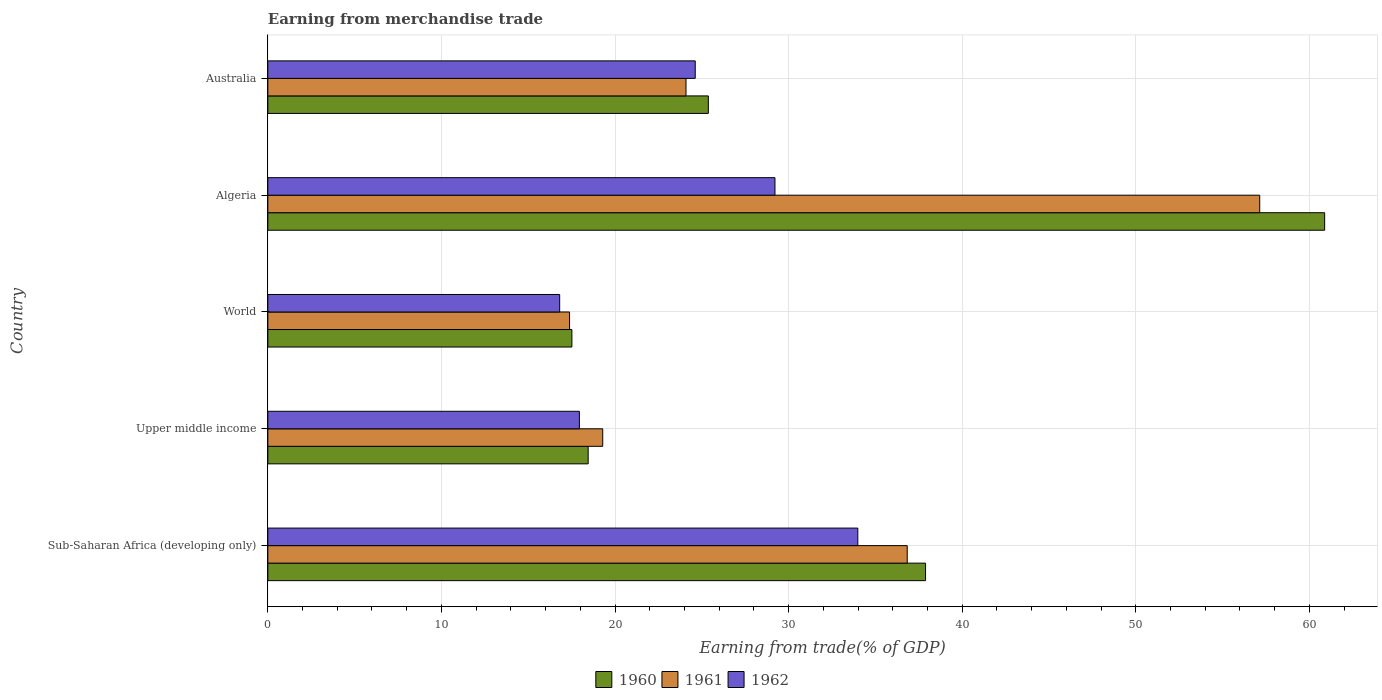How many different coloured bars are there?
Make the answer very short. 3. How many groups of bars are there?
Your answer should be compact. 5. Are the number of bars on each tick of the Y-axis equal?
Your answer should be very brief. Yes. How many bars are there on the 4th tick from the bottom?
Your answer should be compact. 3. What is the label of the 1st group of bars from the top?
Ensure brevity in your answer.  Australia. In how many cases, is the number of bars for a given country not equal to the number of legend labels?
Give a very brief answer. 0. What is the earnings from trade in 1960 in Algeria?
Keep it short and to the point. 60.88. Across all countries, what is the maximum earnings from trade in 1961?
Give a very brief answer. 57.14. Across all countries, what is the minimum earnings from trade in 1961?
Offer a very short reply. 17.38. In which country was the earnings from trade in 1960 maximum?
Give a very brief answer. Algeria. What is the total earnings from trade in 1960 in the graph?
Provide a succinct answer. 160.12. What is the difference between the earnings from trade in 1960 in Algeria and that in Sub-Saharan Africa (developing only)?
Keep it short and to the point. 22.99. What is the difference between the earnings from trade in 1961 in Upper middle income and the earnings from trade in 1962 in World?
Your answer should be very brief. 2.48. What is the average earnings from trade in 1960 per country?
Your response must be concise. 32.02. What is the difference between the earnings from trade in 1960 and earnings from trade in 1962 in Algeria?
Your answer should be compact. 31.67. In how many countries, is the earnings from trade in 1960 greater than 10 %?
Make the answer very short. 5. What is the ratio of the earnings from trade in 1960 in Algeria to that in Australia?
Offer a very short reply. 2.4. Is the earnings from trade in 1960 in Algeria less than that in Australia?
Make the answer very short. No. What is the difference between the highest and the second highest earnings from trade in 1962?
Offer a terse response. 4.77. What is the difference between the highest and the lowest earnings from trade in 1960?
Ensure brevity in your answer.  43.37. Is it the case that in every country, the sum of the earnings from trade in 1960 and earnings from trade in 1962 is greater than the earnings from trade in 1961?
Offer a very short reply. Yes. How many bars are there?
Make the answer very short. 15. Are all the bars in the graph horizontal?
Your answer should be very brief. Yes. What is the difference between two consecutive major ticks on the X-axis?
Make the answer very short. 10. Are the values on the major ticks of X-axis written in scientific E-notation?
Your response must be concise. No. Does the graph contain any zero values?
Provide a succinct answer. No. How many legend labels are there?
Offer a very short reply. 3. What is the title of the graph?
Give a very brief answer. Earning from merchandise trade. What is the label or title of the X-axis?
Give a very brief answer. Earning from trade(% of GDP). What is the Earning from trade(% of GDP) of 1960 in Sub-Saharan Africa (developing only)?
Your answer should be very brief. 37.89. What is the Earning from trade(% of GDP) in 1961 in Sub-Saharan Africa (developing only)?
Offer a terse response. 36.84. What is the Earning from trade(% of GDP) of 1962 in Sub-Saharan Africa (developing only)?
Keep it short and to the point. 33.99. What is the Earning from trade(% of GDP) of 1960 in Upper middle income?
Give a very brief answer. 18.45. What is the Earning from trade(% of GDP) in 1961 in Upper middle income?
Your response must be concise. 19.29. What is the Earning from trade(% of GDP) of 1962 in Upper middle income?
Offer a terse response. 17.95. What is the Earning from trade(% of GDP) of 1960 in World?
Make the answer very short. 17.52. What is the Earning from trade(% of GDP) of 1961 in World?
Your answer should be compact. 17.38. What is the Earning from trade(% of GDP) in 1962 in World?
Provide a succinct answer. 16.81. What is the Earning from trade(% of GDP) in 1960 in Algeria?
Your answer should be compact. 60.88. What is the Earning from trade(% of GDP) of 1961 in Algeria?
Offer a terse response. 57.14. What is the Earning from trade(% of GDP) of 1962 in Algeria?
Ensure brevity in your answer.  29.22. What is the Earning from trade(% of GDP) in 1960 in Australia?
Ensure brevity in your answer.  25.38. What is the Earning from trade(% of GDP) of 1961 in Australia?
Your answer should be very brief. 24.09. What is the Earning from trade(% of GDP) in 1962 in Australia?
Provide a short and direct response. 24.62. Across all countries, what is the maximum Earning from trade(% of GDP) in 1960?
Give a very brief answer. 60.88. Across all countries, what is the maximum Earning from trade(% of GDP) of 1961?
Offer a terse response. 57.14. Across all countries, what is the maximum Earning from trade(% of GDP) in 1962?
Your answer should be compact. 33.99. Across all countries, what is the minimum Earning from trade(% of GDP) in 1960?
Give a very brief answer. 17.52. Across all countries, what is the minimum Earning from trade(% of GDP) of 1961?
Your response must be concise. 17.38. Across all countries, what is the minimum Earning from trade(% of GDP) in 1962?
Make the answer very short. 16.81. What is the total Earning from trade(% of GDP) of 1960 in the graph?
Your answer should be compact. 160.12. What is the total Earning from trade(% of GDP) in 1961 in the graph?
Ensure brevity in your answer.  154.75. What is the total Earning from trade(% of GDP) of 1962 in the graph?
Your answer should be compact. 122.59. What is the difference between the Earning from trade(% of GDP) of 1960 in Sub-Saharan Africa (developing only) and that in Upper middle income?
Provide a short and direct response. 19.44. What is the difference between the Earning from trade(% of GDP) of 1961 in Sub-Saharan Africa (developing only) and that in Upper middle income?
Give a very brief answer. 17.54. What is the difference between the Earning from trade(% of GDP) of 1962 in Sub-Saharan Africa (developing only) and that in Upper middle income?
Offer a terse response. 16.04. What is the difference between the Earning from trade(% of GDP) of 1960 in Sub-Saharan Africa (developing only) and that in World?
Keep it short and to the point. 20.37. What is the difference between the Earning from trade(% of GDP) in 1961 in Sub-Saharan Africa (developing only) and that in World?
Your answer should be compact. 19.45. What is the difference between the Earning from trade(% of GDP) of 1962 in Sub-Saharan Africa (developing only) and that in World?
Provide a succinct answer. 17.18. What is the difference between the Earning from trade(% of GDP) in 1960 in Sub-Saharan Africa (developing only) and that in Algeria?
Offer a very short reply. -22.99. What is the difference between the Earning from trade(% of GDP) in 1961 in Sub-Saharan Africa (developing only) and that in Algeria?
Offer a very short reply. -20.31. What is the difference between the Earning from trade(% of GDP) of 1962 in Sub-Saharan Africa (developing only) and that in Algeria?
Your answer should be compact. 4.77. What is the difference between the Earning from trade(% of GDP) in 1960 in Sub-Saharan Africa (developing only) and that in Australia?
Offer a very short reply. 12.51. What is the difference between the Earning from trade(% of GDP) of 1961 in Sub-Saharan Africa (developing only) and that in Australia?
Ensure brevity in your answer.  12.74. What is the difference between the Earning from trade(% of GDP) of 1962 in Sub-Saharan Africa (developing only) and that in Australia?
Keep it short and to the point. 9.37. What is the difference between the Earning from trade(% of GDP) in 1960 in Upper middle income and that in World?
Your answer should be very brief. 0.94. What is the difference between the Earning from trade(% of GDP) of 1961 in Upper middle income and that in World?
Your answer should be very brief. 1.91. What is the difference between the Earning from trade(% of GDP) of 1962 in Upper middle income and that in World?
Make the answer very short. 1.14. What is the difference between the Earning from trade(% of GDP) in 1960 in Upper middle income and that in Algeria?
Give a very brief answer. -42.43. What is the difference between the Earning from trade(% of GDP) in 1961 in Upper middle income and that in Algeria?
Give a very brief answer. -37.85. What is the difference between the Earning from trade(% of GDP) of 1962 in Upper middle income and that in Algeria?
Provide a succinct answer. -11.27. What is the difference between the Earning from trade(% of GDP) in 1960 in Upper middle income and that in Australia?
Ensure brevity in your answer.  -6.92. What is the difference between the Earning from trade(% of GDP) of 1961 in Upper middle income and that in Australia?
Your answer should be very brief. -4.8. What is the difference between the Earning from trade(% of GDP) of 1962 in Upper middle income and that in Australia?
Offer a terse response. -6.67. What is the difference between the Earning from trade(% of GDP) of 1960 in World and that in Algeria?
Offer a terse response. -43.37. What is the difference between the Earning from trade(% of GDP) of 1961 in World and that in Algeria?
Provide a succinct answer. -39.76. What is the difference between the Earning from trade(% of GDP) of 1962 in World and that in Algeria?
Offer a very short reply. -12.4. What is the difference between the Earning from trade(% of GDP) in 1960 in World and that in Australia?
Offer a terse response. -7.86. What is the difference between the Earning from trade(% of GDP) of 1961 in World and that in Australia?
Offer a very short reply. -6.71. What is the difference between the Earning from trade(% of GDP) in 1962 in World and that in Australia?
Offer a terse response. -7.81. What is the difference between the Earning from trade(% of GDP) in 1960 in Algeria and that in Australia?
Offer a very short reply. 35.51. What is the difference between the Earning from trade(% of GDP) in 1961 in Algeria and that in Australia?
Offer a terse response. 33.05. What is the difference between the Earning from trade(% of GDP) of 1962 in Algeria and that in Australia?
Provide a succinct answer. 4.59. What is the difference between the Earning from trade(% of GDP) of 1960 in Sub-Saharan Africa (developing only) and the Earning from trade(% of GDP) of 1961 in Upper middle income?
Offer a terse response. 18.6. What is the difference between the Earning from trade(% of GDP) in 1960 in Sub-Saharan Africa (developing only) and the Earning from trade(% of GDP) in 1962 in Upper middle income?
Give a very brief answer. 19.94. What is the difference between the Earning from trade(% of GDP) in 1961 in Sub-Saharan Africa (developing only) and the Earning from trade(% of GDP) in 1962 in Upper middle income?
Keep it short and to the point. 18.89. What is the difference between the Earning from trade(% of GDP) of 1960 in Sub-Saharan Africa (developing only) and the Earning from trade(% of GDP) of 1961 in World?
Your answer should be compact. 20.51. What is the difference between the Earning from trade(% of GDP) of 1960 in Sub-Saharan Africa (developing only) and the Earning from trade(% of GDP) of 1962 in World?
Your answer should be compact. 21.08. What is the difference between the Earning from trade(% of GDP) of 1961 in Sub-Saharan Africa (developing only) and the Earning from trade(% of GDP) of 1962 in World?
Make the answer very short. 20.02. What is the difference between the Earning from trade(% of GDP) in 1960 in Sub-Saharan Africa (developing only) and the Earning from trade(% of GDP) in 1961 in Algeria?
Make the answer very short. -19.25. What is the difference between the Earning from trade(% of GDP) in 1960 in Sub-Saharan Africa (developing only) and the Earning from trade(% of GDP) in 1962 in Algeria?
Offer a very short reply. 8.67. What is the difference between the Earning from trade(% of GDP) in 1961 in Sub-Saharan Africa (developing only) and the Earning from trade(% of GDP) in 1962 in Algeria?
Offer a very short reply. 7.62. What is the difference between the Earning from trade(% of GDP) of 1960 in Sub-Saharan Africa (developing only) and the Earning from trade(% of GDP) of 1961 in Australia?
Keep it short and to the point. 13.8. What is the difference between the Earning from trade(% of GDP) in 1960 in Sub-Saharan Africa (developing only) and the Earning from trade(% of GDP) in 1962 in Australia?
Your answer should be compact. 13.27. What is the difference between the Earning from trade(% of GDP) in 1961 in Sub-Saharan Africa (developing only) and the Earning from trade(% of GDP) in 1962 in Australia?
Your answer should be compact. 12.21. What is the difference between the Earning from trade(% of GDP) of 1960 in Upper middle income and the Earning from trade(% of GDP) of 1961 in World?
Your response must be concise. 1.07. What is the difference between the Earning from trade(% of GDP) of 1960 in Upper middle income and the Earning from trade(% of GDP) of 1962 in World?
Your answer should be very brief. 1.64. What is the difference between the Earning from trade(% of GDP) of 1961 in Upper middle income and the Earning from trade(% of GDP) of 1962 in World?
Make the answer very short. 2.48. What is the difference between the Earning from trade(% of GDP) of 1960 in Upper middle income and the Earning from trade(% of GDP) of 1961 in Algeria?
Provide a short and direct response. -38.69. What is the difference between the Earning from trade(% of GDP) of 1960 in Upper middle income and the Earning from trade(% of GDP) of 1962 in Algeria?
Provide a short and direct response. -10.76. What is the difference between the Earning from trade(% of GDP) in 1961 in Upper middle income and the Earning from trade(% of GDP) in 1962 in Algeria?
Provide a succinct answer. -9.92. What is the difference between the Earning from trade(% of GDP) of 1960 in Upper middle income and the Earning from trade(% of GDP) of 1961 in Australia?
Give a very brief answer. -5.64. What is the difference between the Earning from trade(% of GDP) of 1960 in Upper middle income and the Earning from trade(% of GDP) of 1962 in Australia?
Provide a succinct answer. -6.17. What is the difference between the Earning from trade(% of GDP) in 1961 in Upper middle income and the Earning from trade(% of GDP) in 1962 in Australia?
Provide a succinct answer. -5.33. What is the difference between the Earning from trade(% of GDP) of 1960 in World and the Earning from trade(% of GDP) of 1961 in Algeria?
Your response must be concise. -39.63. What is the difference between the Earning from trade(% of GDP) in 1960 in World and the Earning from trade(% of GDP) in 1962 in Algeria?
Give a very brief answer. -11.7. What is the difference between the Earning from trade(% of GDP) in 1961 in World and the Earning from trade(% of GDP) in 1962 in Algeria?
Your response must be concise. -11.83. What is the difference between the Earning from trade(% of GDP) of 1960 in World and the Earning from trade(% of GDP) of 1961 in Australia?
Offer a very short reply. -6.57. What is the difference between the Earning from trade(% of GDP) in 1960 in World and the Earning from trade(% of GDP) in 1962 in Australia?
Give a very brief answer. -7.11. What is the difference between the Earning from trade(% of GDP) in 1961 in World and the Earning from trade(% of GDP) in 1962 in Australia?
Provide a short and direct response. -7.24. What is the difference between the Earning from trade(% of GDP) of 1960 in Algeria and the Earning from trade(% of GDP) of 1961 in Australia?
Keep it short and to the point. 36.79. What is the difference between the Earning from trade(% of GDP) in 1960 in Algeria and the Earning from trade(% of GDP) in 1962 in Australia?
Your answer should be very brief. 36.26. What is the difference between the Earning from trade(% of GDP) of 1961 in Algeria and the Earning from trade(% of GDP) of 1962 in Australia?
Provide a succinct answer. 32.52. What is the average Earning from trade(% of GDP) of 1960 per country?
Offer a very short reply. 32.02. What is the average Earning from trade(% of GDP) in 1961 per country?
Your answer should be very brief. 30.95. What is the average Earning from trade(% of GDP) of 1962 per country?
Keep it short and to the point. 24.52. What is the difference between the Earning from trade(% of GDP) in 1960 and Earning from trade(% of GDP) in 1961 in Sub-Saharan Africa (developing only)?
Provide a short and direct response. 1.06. What is the difference between the Earning from trade(% of GDP) in 1960 and Earning from trade(% of GDP) in 1962 in Sub-Saharan Africa (developing only)?
Your answer should be compact. 3.9. What is the difference between the Earning from trade(% of GDP) of 1961 and Earning from trade(% of GDP) of 1962 in Sub-Saharan Africa (developing only)?
Your response must be concise. 2.85. What is the difference between the Earning from trade(% of GDP) in 1960 and Earning from trade(% of GDP) in 1961 in Upper middle income?
Provide a short and direct response. -0.84. What is the difference between the Earning from trade(% of GDP) of 1960 and Earning from trade(% of GDP) of 1962 in Upper middle income?
Ensure brevity in your answer.  0.51. What is the difference between the Earning from trade(% of GDP) in 1961 and Earning from trade(% of GDP) in 1962 in Upper middle income?
Provide a short and direct response. 1.34. What is the difference between the Earning from trade(% of GDP) of 1960 and Earning from trade(% of GDP) of 1961 in World?
Your answer should be compact. 0.13. What is the difference between the Earning from trade(% of GDP) in 1960 and Earning from trade(% of GDP) in 1962 in World?
Provide a short and direct response. 0.7. What is the difference between the Earning from trade(% of GDP) in 1961 and Earning from trade(% of GDP) in 1962 in World?
Make the answer very short. 0.57. What is the difference between the Earning from trade(% of GDP) in 1960 and Earning from trade(% of GDP) in 1961 in Algeria?
Offer a very short reply. 3.74. What is the difference between the Earning from trade(% of GDP) in 1960 and Earning from trade(% of GDP) in 1962 in Algeria?
Keep it short and to the point. 31.67. What is the difference between the Earning from trade(% of GDP) in 1961 and Earning from trade(% of GDP) in 1962 in Algeria?
Offer a terse response. 27.93. What is the difference between the Earning from trade(% of GDP) in 1960 and Earning from trade(% of GDP) in 1961 in Australia?
Your answer should be compact. 1.29. What is the difference between the Earning from trade(% of GDP) of 1960 and Earning from trade(% of GDP) of 1962 in Australia?
Ensure brevity in your answer.  0.76. What is the difference between the Earning from trade(% of GDP) of 1961 and Earning from trade(% of GDP) of 1962 in Australia?
Your answer should be compact. -0.53. What is the ratio of the Earning from trade(% of GDP) of 1960 in Sub-Saharan Africa (developing only) to that in Upper middle income?
Provide a short and direct response. 2.05. What is the ratio of the Earning from trade(% of GDP) of 1961 in Sub-Saharan Africa (developing only) to that in Upper middle income?
Provide a succinct answer. 1.91. What is the ratio of the Earning from trade(% of GDP) of 1962 in Sub-Saharan Africa (developing only) to that in Upper middle income?
Offer a terse response. 1.89. What is the ratio of the Earning from trade(% of GDP) in 1960 in Sub-Saharan Africa (developing only) to that in World?
Give a very brief answer. 2.16. What is the ratio of the Earning from trade(% of GDP) in 1961 in Sub-Saharan Africa (developing only) to that in World?
Your answer should be compact. 2.12. What is the ratio of the Earning from trade(% of GDP) in 1962 in Sub-Saharan Africa (developing only) to that in World?
Your response must be concise. 2.02. What is the ratio of the Earning from trade(% of GDP) in 1960 in Sub-Saharan Africa (developing only) to that in Algeria?
Give a very brief answer. 0.62. What is the ratio of the Earning from trade(% of GDP) in 1961 in Sub-Saharan Africa (developing only) to that in Algeria?
Make the answer very short. 0.64. What is the ratio of the Earning from trade(% of GDP) in 1962 in Sub-Saharan Africa (developing only) to that in Algeria?
Your answer should be compact. 1.16. What is the ratio of the Earning from trade(% of GDP) of 1960 in Sub-Saharan Africa (developing only) to that in Australia?
Provide a short and direct response. 1.49. What is the ratio of the Earning from trade(% of GDP) in 1961 in Sub-Saharan Africa (developing only) to that in Australia?
Make the answer very short. 1.53. What is the ratio of the Earning from trade(% of GDP) in 1962 in Sub-Saharan Africa (developing only) to that in Australia?
Your answer should be compact. 1.38. What is the ratio of the Earning from trade(% of GDP) in 1960 in Upper middle income to that in World?
Your answer should be very brief. 1.05. What is the ratio of the Earning from trade(% of GDP) of 1961 in Upper middle income to that in World?
Your answer should be compact. 1.11. What is the ratio of the Earning from trade(% of GDP) in 1962 in Upper middle income to that in World?
Offer a very short reply. 1.07. What is the ratio of the Earning from trade(% of GDP) in 1960 in Upper middle income to that in Algeria?
Provide a succinct answer. 0.3. What is the ratio of the Earning from trade(% of GDP) of 1961 in Upper middle income to that in Algeria?
Make the answer very short. 0.34. What is the ratio of the Earning from trade(% of GDP) of 1962 in Upper middle income to that in Algeria?
Keep it short and to the point. 0.61. What is the ratio of the Earning from trade(% of GDP) in 1960 in Upper middle income to that in Australia?
Offer a terse response. 0.73. What is the ratio of the Earning from trade(% of GDP) in 1961 in Upper middle income to that in Australia?
Provide a succinct answer. 0.8. What is the ratio of the Earning from trade(% of GDP) in 1962 in Upper middle income to that in Australia?
Your answer should be very brief. 0.73. What is the ratio of the Earning from trade(% of GDP) of 1960 in World to that in Algeria?
Keep it short and to the point. 0.29. What is the ratio of the Earning from trade(% of GDP) in 1961 in World to that in Algeria?
Ensure brevity in your answer.  0.3. What is the ratio of the Earning from trade(% of GDP) of 1962 in World to that in Algeria?
Keep it short and to the point. 0.58. What is the ratio of the Earning from trade(% of GDP) of 1960 in World to that in Australia?
Make the answer very short. 0.69. What is the ratio of the Earning from trade(% of GDP) in 1961 in World to that in Australia?
Offer a very short reply. 0.72. What is the ratio of the Earning from trade(% of GDP) of 1962 in World to that in Australia?
Make the answer very short. 0.68. What is the ratio of the Earning from trade(% of GDP) of 1960 in Algeria to that in Australia?
Keep it short and to the point. 2.4. What is the ratio of the Earning from trade(% of GDP) in 1961 in Algeria to that in Australia?
Give a very brief answer. 2.37. What is the ratio of the Earning from trade(% of GDP) of 1962 in Algeria to that in Australia?
Your answer should be compact. 1.19. What is the difference between the highest and the second highest Earning from trade(% of GDP) in 1960?
Your answer should be very brief. 22.99. What is the difference between the highest and the second highest Earning from trade(% of GDP) of 1961?
Your answer should be very brief. 20.31. What is the difference between the highest and the second highest Earning from trade(% of GDP) in 1962?
Make the answer very short. 4.77. What is the difference between the highest and the lowest Earning from trade(% of GDP) in 1960?
Provide a short and direct response. 43.37. What is the difference between the highest and the lowest Earning from trade(% of GDP) of 1961?
Your answer should be compact. 39.76. What is the difference between the highest and the lowest Earning from trade(% of GDP) in 1962?
Keep it short and to the point. 17.18. 